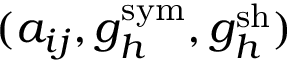Convert formula to latex. <formula><loc_0><loc_0><loc_500><loc_500>( { a } _ { i j } , { g } _ { h } ^ { s y m } , { g } _ { h } ^ { s h } )</formula> 